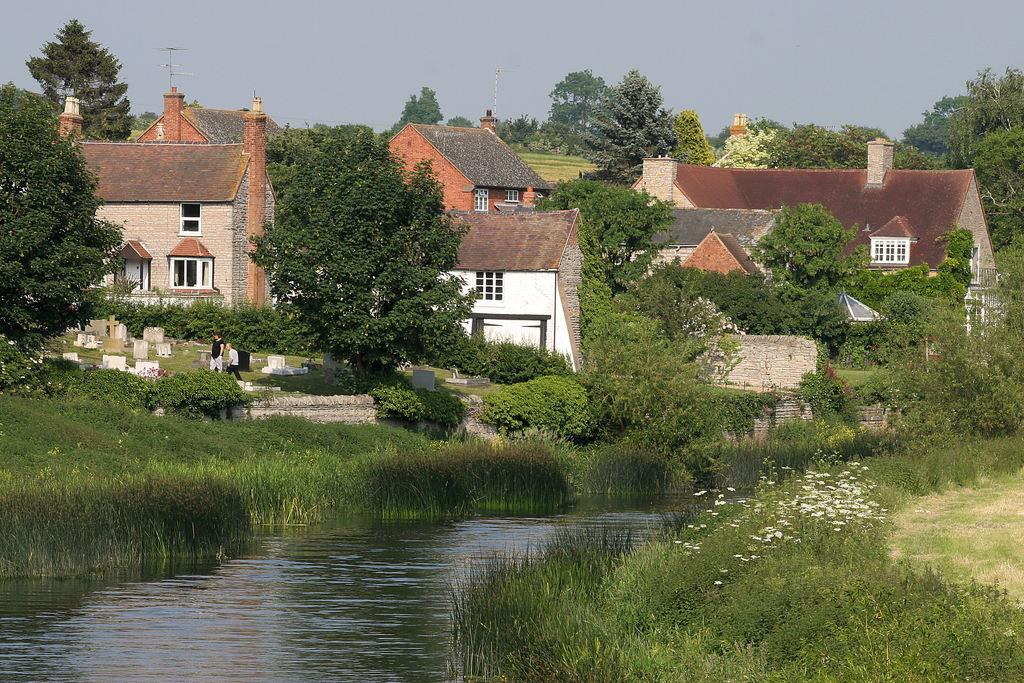What is one of the natural elements present in the image? There is water in the image. What type of plants can be seen in the image? There are plants with flowers in the image. What type of vegetation is present in the image? Grass is present in the image. What type of man-made structures are visible in the image? There are buildings in the image. What type of area is depicted in the image? There is a graveyard in the image. How many people are present in the image? There are two persons standing in the image. What type of trees are visible in the image? Trees are visible in the image. What part of the natural environment is visible in the image? The sky is visible in the image. What type of rat can be seen wearing a crown in the image? There is no rat or crown present in the image. What type of tail is visible in the image? There is no tail present in the image. 